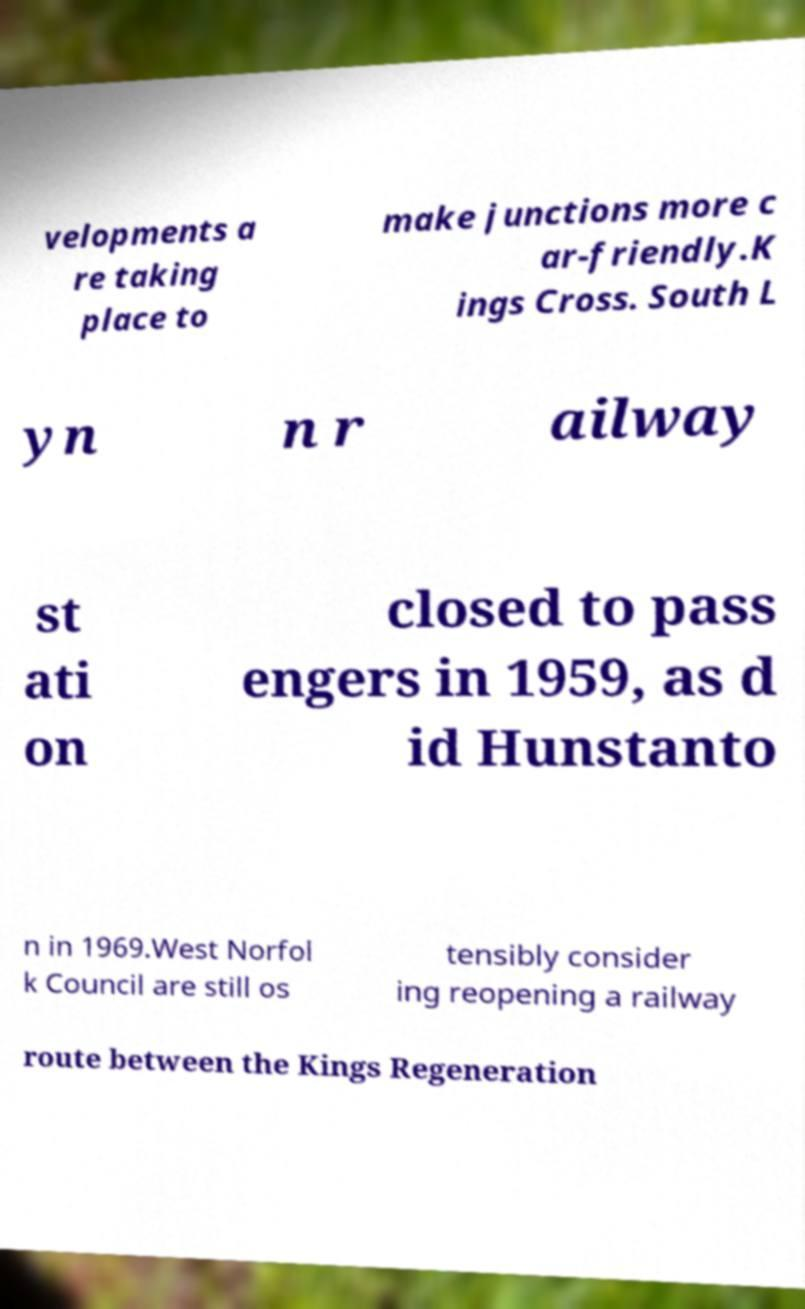Please identify and transcribe the text found in this image. velopments a re taking place to make junctions more c ar-friendly.K ings Cross. South L yn n r ailway st ati on closed to pass engers in 1959, as d id Hunstanto n in 1969.West Norfol k Council are still os tensibly consider ing reopening a railway route between the Kings Regeneration 